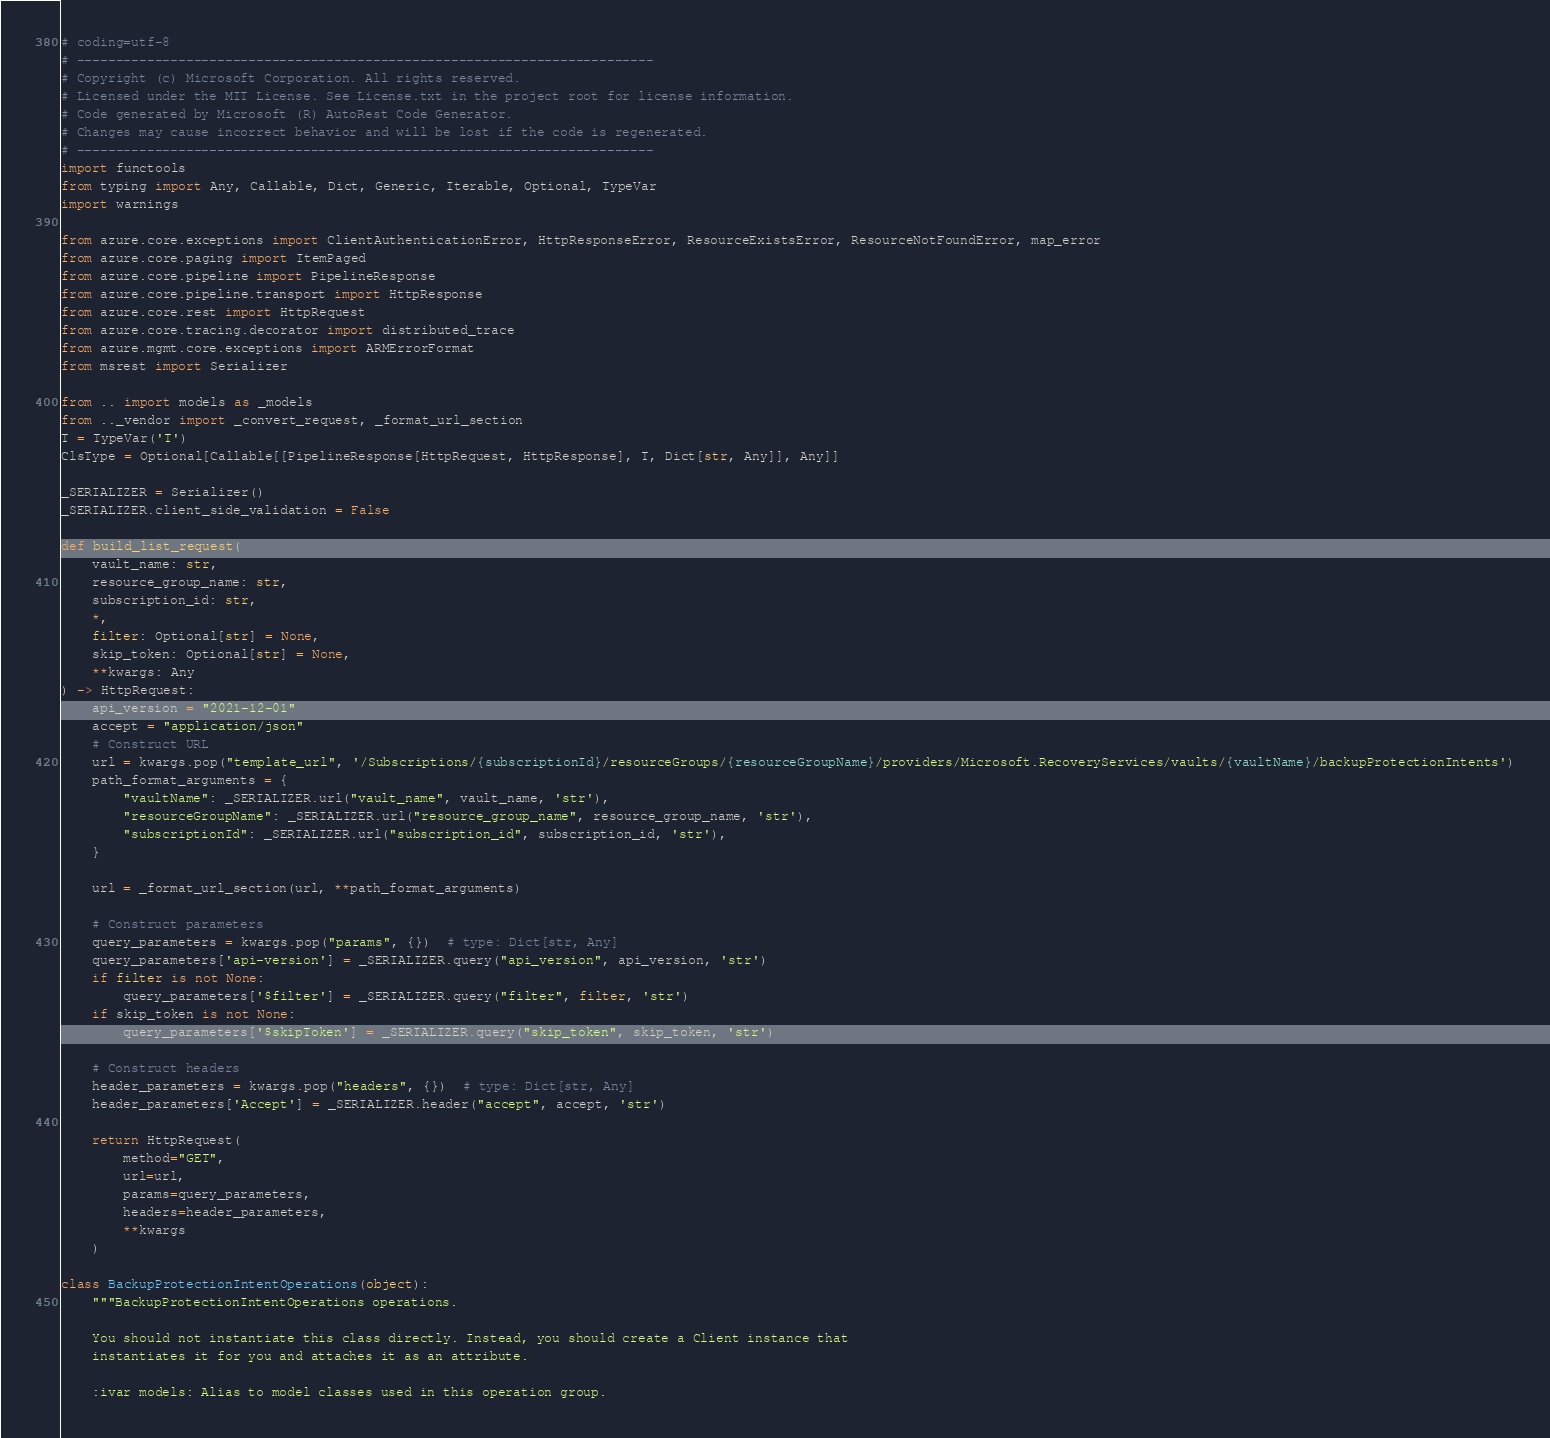<code> <loc_0><loc_0><loc_500><loc_500><_Python_># coding=utf-8
# --------------------------------------------------------------------------
# Copyright (c) Microsoft Corporation. All rights reserved.
# Licensed under the MIT License. See License.txt in the project root for license information.
# Code generated by Microsoft (R) AutoRest Code Generator.
# Changes may cause incorrect behavior and will be lost if the code is regenerated.
# --------------------------------------------------------------------------
import functools
from typing import Any, Callable, Dict, Generic, Iterable, Optional, TypeVar
import warnings

from azure.core.exceptions import ClientAuthenticationError, HttpResponseError, ResourceExistsError, ResourceNotFoundError, map_error
from azure.core.paging import ItemPaged
from azure.core.pipeline import PipelineResponse
from azure.core.pipeline.transport import HttpResponse
from azure.core.rest import HttpRequest
from azure.core.tracing.decorator import distributed_trace
from azure.mgmt.core.exceptions import ARMErrorFormat
from msrest import Serializer

from .. import models as _models
from .._vendor import _convert_request, _format_url_section
T = TypeVar('T')
ClsType = Optional[Callable[[PipelineResponse[HttpRequest, HttpResponse], T, Dict[str, Any]], Any]]

_SERIALIZER = Serializer()
_SERIALIZER.client_side_validation = False

def build_list_request(
    vault_name: str,
    resource_group_name: str,
    subscription_id: str,
    *,
    filter: Optional[str] = None,
    skip_token: Optional[str] = None,
    **kwargs: Any
) -> HttpRequest:
    api_version = "2021-12-01"
    accept = "application/json"
    # Construct URL
    url = kwargs.pop("template_url", '/Subscriptions/{subscriptionId}/resourceGroups/{resourceGroupName}/providers/Microsoft.RecoveryServices/vaults/{vaultName}/backupProtectionIntents')
    path_format_arguments = {
        "vaultName": _SERIALIZER.url("vault_name", vault_name, 'str'),
        "resourceGroupName": _SERIALIZER.url("resource_group_name", resource_group_name, 'str'),
        "subscriptionId": _SERIALIZER.url("subscription_id", subscription_id, 'str'),
    }

    url = _format_url_section(url, **path_format_arguments)

    # Construct parameters
    query_parameters = kwargs.pop("params", {})  # type: Dict[str, Any]
    query_parameters['api-version'] = _SERIALIZER.query("api_version", api_version, 'str')
    if filter is not None:
        query_parameters['$filter'] = _SERIALIZER.query("filter", filter, 'str')
    if skip_token is not None:
        query_parameters['$skipToken'] = _SERIALIZER.query("skip_token", skip_token, 'str')

    # Construct headers
    header_parameters = kwargs.pop("headers", {})  # type: Dict[str, Any]
    header_parameters['Accept'] = _SERIALIZER.header("accept", accept, 'str')

    return HttpRequest(
        method="GET",
        url=url,
        params=query_parameters,
        headers=header_parameters,
        **kwargs
    )

class BackupProtectionIntentOperations(object):
    """BackupProtectionIntentOperations operations.

    You should not instantiate this class directly. Instead, you should create a Client instance that
    instantiates it for you and attaches it as an attribute.

    :ivar models: Alias to model classes used in this operation group.</code> 